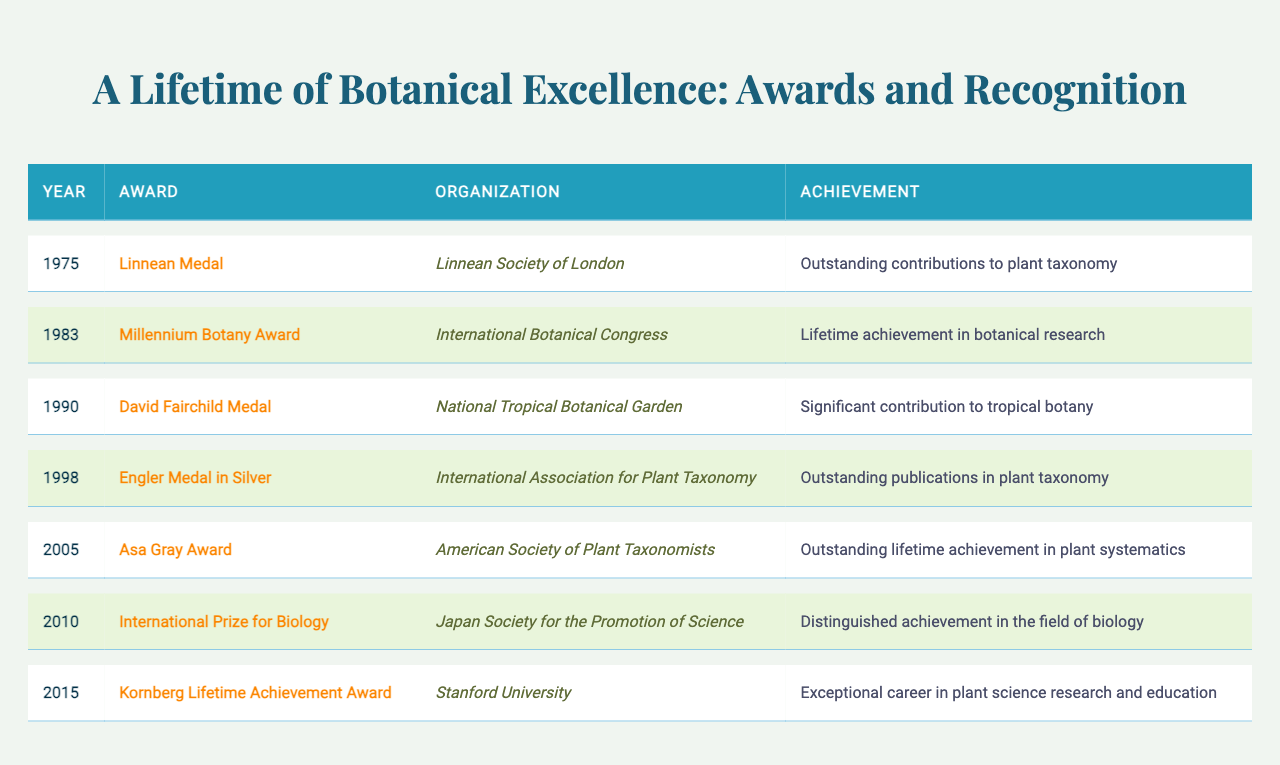What award did the botanist receive in 1983? The table shows that in 1983, the botanist received the "Millennium Botany Award."
Answer: Millennium Botany Award How many awards did the botanist receive in total? Counting each entry in the table, there are 7 awards listed.
Answer: 7 Which organization awarded the "David Fairchild Medal"? The table indicates that the "David Fairchild Medal" was awarded by the "National Tropical Botanical Garden."
Answer: National Tropical Botanical Garden Was there an award for lifetime achievement in botanical research? The table indicates that the "Millennium Botany Award" in 1983 is for lifetime achievement in botanical research, confirming this is true.
Answer: Yes Which two awards did the botanist receive in the 1990s? By referencing the table, the awards received in the 1990s are the "David Fairchild Medal" in 1990 and the "Engler Medal in Silver" in 1998.
Answer: David Fairchild Medal, Engler Medal in Silver What is the earliest award mentioned in the table? The table shows that the earliest award is the "Linnean Medal" received in 1975.
Answer: Linnean Medal Which award has an achievement related to plant systematics? The "Asa Gray Award" awarded in 2005 is specifically noted for outstanding lifetime achievement in plant systematics.
Answer: Asa Gray Award Which years did the botanist receive awards consecutively? By reviewing the years listed in the table, the botanist received awards in consecutive years only from 1998 to 2005 (Engler Medal in Silver in 1998 and Asa Gray Award in 2005).
Answer: 1998, 2005 What is the latest award mentioned in the table, and what was it for? According to the table, the latest award is the "Kornberg Lifetime Achievement Award" received in 2015, which recognizes exceptional career in plant science research and education.
Answer: Kornberg Lifetime Achievement Award, exceptional career in plant science research and education Which award received from Japan Society for the Promotion of Science was about achievement in biology? The table indicates that the award from the Japan Society for the Promotion of Science is the "International Prize for Biology," which is specifically for distinguished achievement in the field of biology.
Answer: International Prize for Biology 